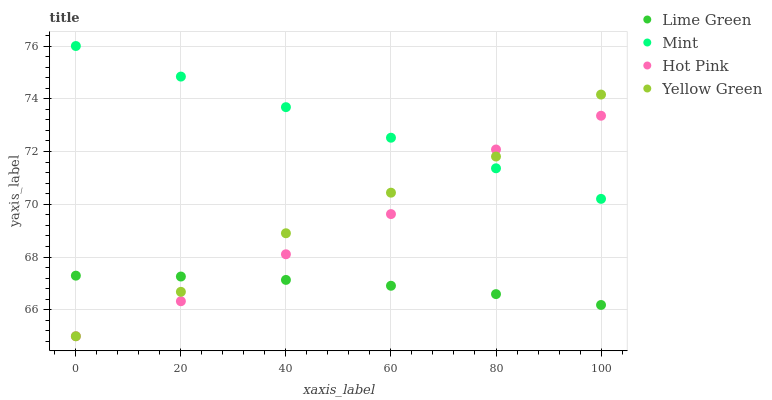Does Lime Green have the minimum area under the curve?
Answer yes or no. Yes. Does Mint have the maximum area under the curve?
Answer yes or no. Yes. Does Hot Pink have the minimum area under the curve?
Answer yes or no. No. Does Hot Pink have the maximum area under the curve?
Answer yes or no. No. Is Mint the smoothest?
Answer yes or no. Yes. Is Hot Pink the roughest?
Answer yes or no. Yes. Is Lime Green the smoothest?
Answer yes or no. No. Is Lime Green the roughest?
Answer yes or no. No. Does Hot Pink have the lowest value?
Answer yes or no. Yes. Does Lime Green have the lowest value?
Answer yes or no. No. Does Mint have the highest value?
Answer yes or no. Yes. Does Hot Pink have the highest value?
Answer yes or no. No. Is Lime Green less than Mint?
Answer yes or no. Yes. Is Mint greater than Lime Green?
Answer yes or no. Yes. Does Hot Pink intersect Lime Green?
Answer yes or no. Yes. Is Hot Pink less than Lime Green?
Answer yes or no. No. Is Hot Pink greater than Lime Green?
Answer yes or no. No. Does Lime Green intersect Mint?
Answer yes or no. No. 